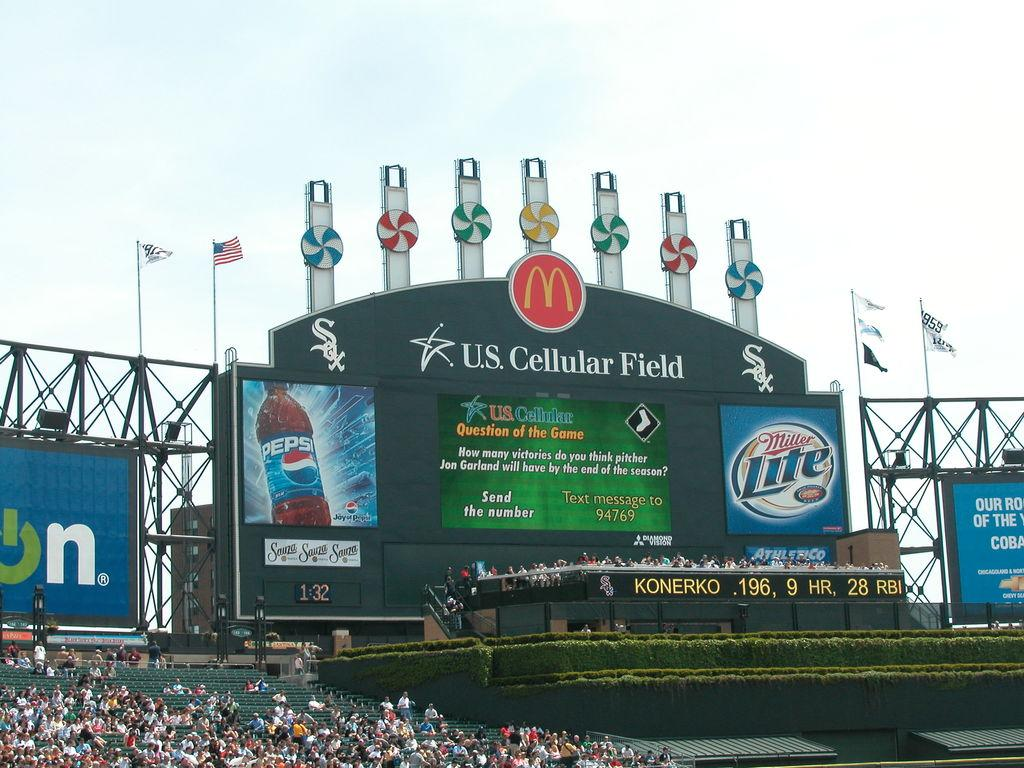Provide a one-sentence caption for the provided image. A sign at US Cellular Field with ads for Miller Lite and Pepsi. 